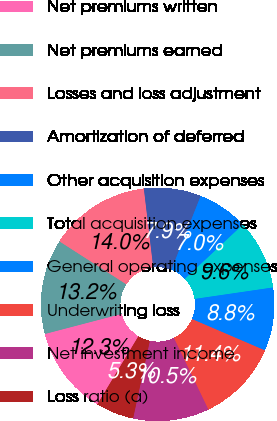<chart> <loc_0><loc_0><loc_500><loc_500><pie_chart><fcel>Net premiums written<fcel>Net premiums earned<fcel>Losses and loss adjustment<fcel>Amortization of deferred<fcel>Other acquisition expenses<fcel>Total acquisition expenses<fcel>General operating expenses<fcel>Underwriting loss<fcel>Net investment income<fcel>Loss ratio (a)<nl><fcel>12.28%<fcel>13.16%<fcel>14.03%<fcel>7.9%<fcel>7.02%<fcel>9.65%<fcel>8.77%<fcel>11.4%<fcel>10.53%<fcel>5.26%<nl></chart> 